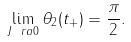Convert formula to latex. <formula><loc_0><loc_0><loc_500><loc_500>\lim _ { J \ r a 0 } { \theta _ { 2 } ( t _ { + } ) } = \frac { \pi } { 2 } .</formula> 